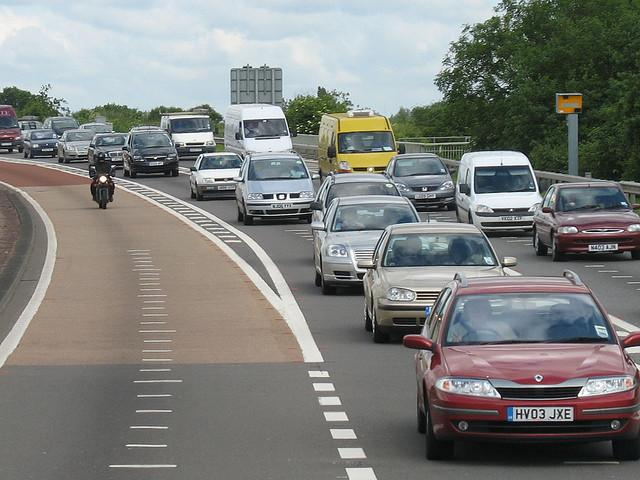Who are the roads for?

Choices:
A) drivers
B) pedestrians
C) downtown
D) directions drivers 